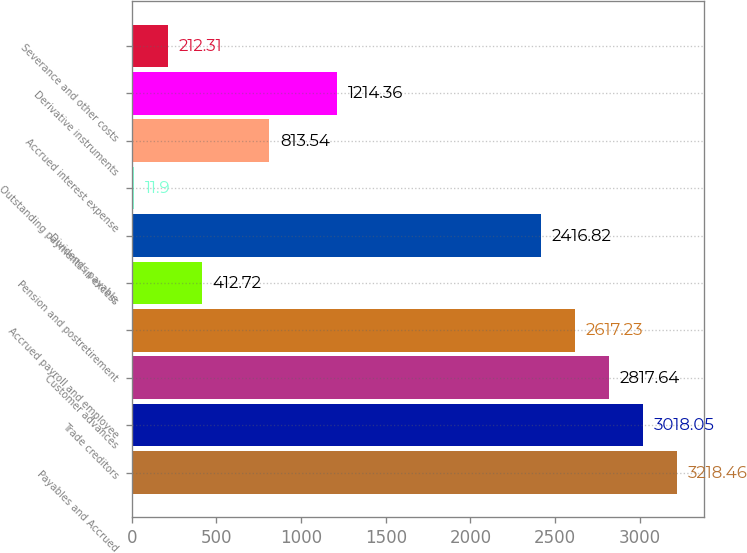Convert chart. <chart><loc_0><loc_0><loc_500><loc_500><bar_chart><fcel>Payables and Accrued<fcel>Trade creditors<fcel>Customer advances<fcel>Accrued payroll and employee<fcel>Pension and postretirement<fcel>Dividends payable<fcel>Outstanding payments in excess<fcel>Accrued interest expense<fcel>Derivative instruments<fcel>Severance and other costs<nl><fcel>3218.46<fcel>3018.05<fcel>2817.64<fcel>2617.23<fcel>412.72<fcel>2416.82<fcel>11.9<fcel>813.54<fcel>1214.36<fcel>212.31<nl></chart> 